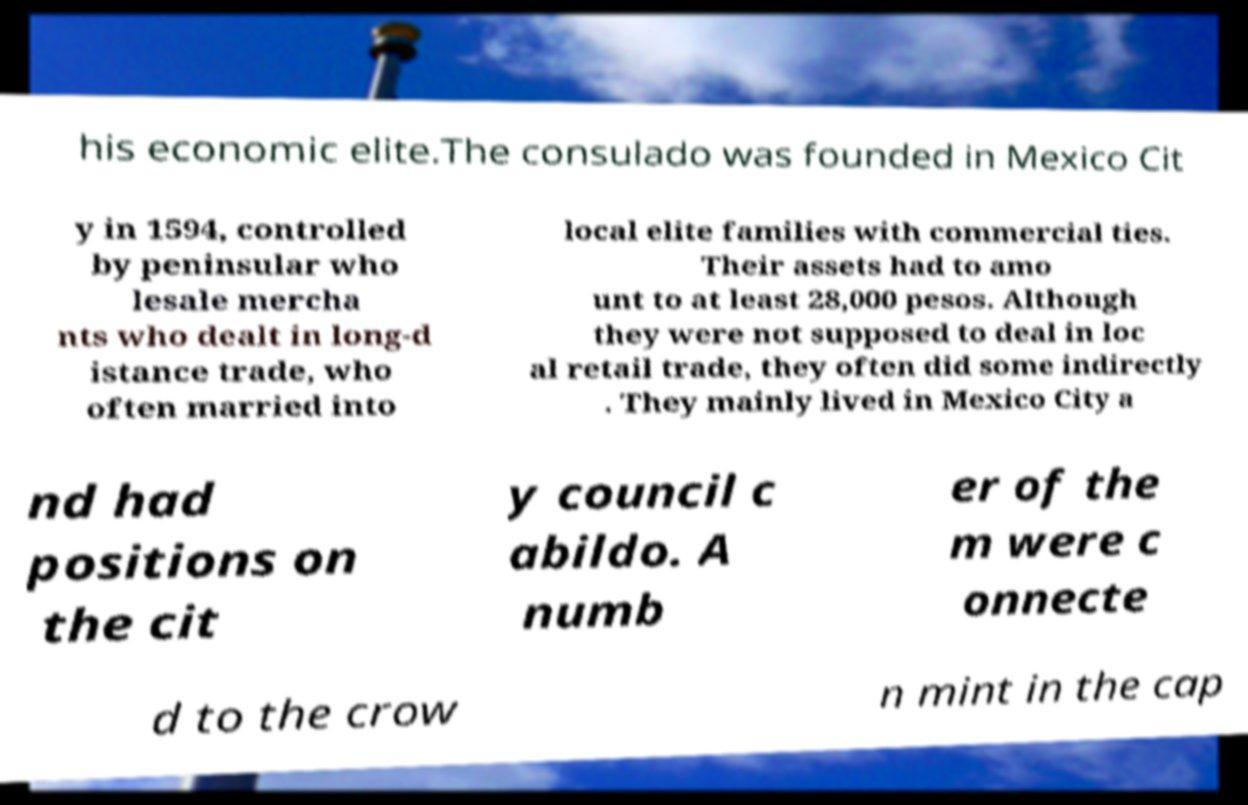There's text embedded in this image that I need extracted. Can you transcribe it verbatim? his economic elite.The consulado was founded in Mexico Cit y in 1594, controlled by peninsular who lesale mercha nts who dealt in long-d istance trade, who often married into local elite families with commercial ties. Their assets had to amo unt to at least 28,000 pesos. Although they were not supposed to deal in loc al retail trade, they often did some indirectly . They mainly lived in Mexico City a nd had positions on the cit y council c abildo. A numb er of the m were c onnecte d to the crow n mint in the cap 